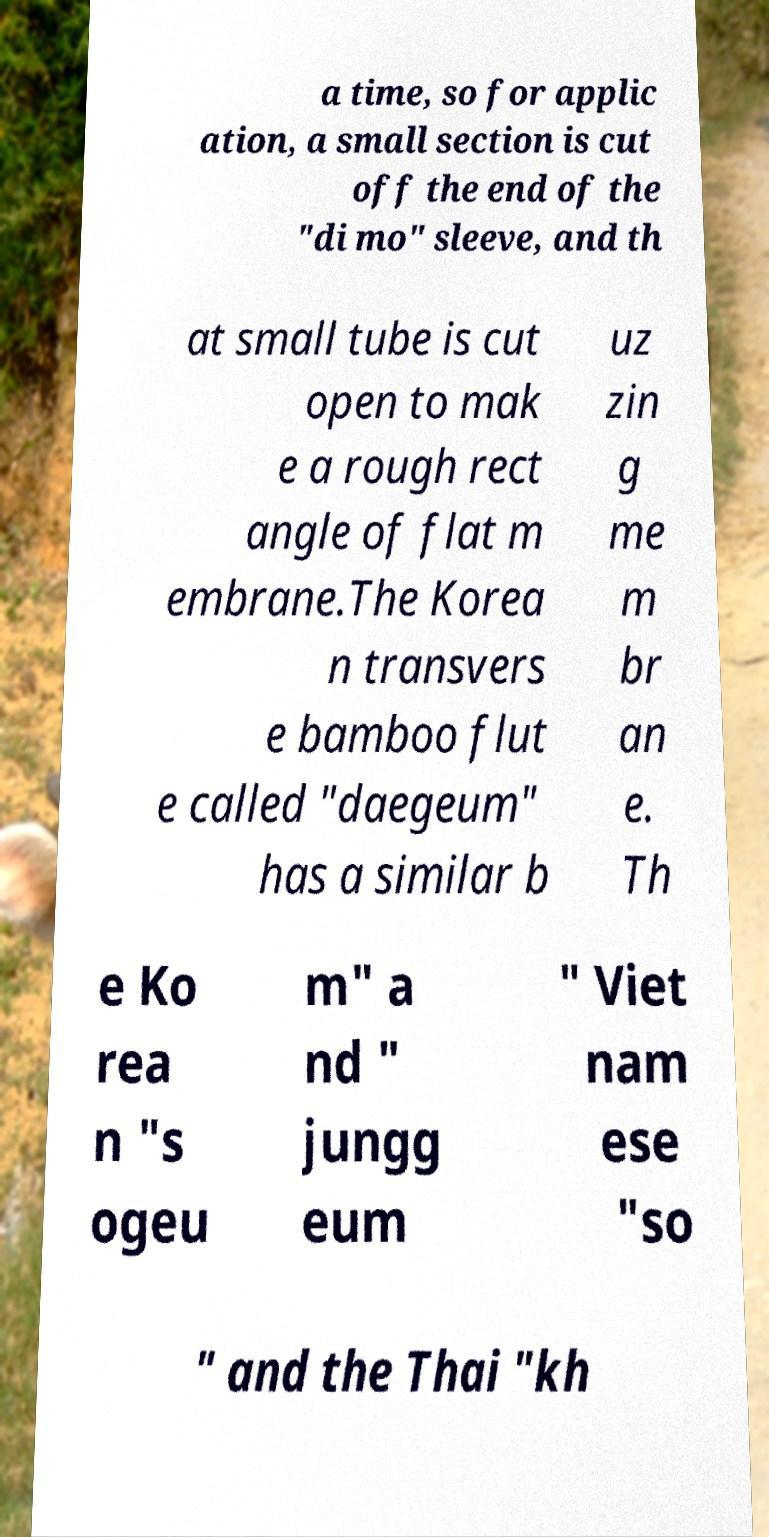Please read and relay the text visible in this image. What does it say? a time, so for applic ation, a small section is cut off the end of the "di mo" sleeve, and th at small tube is cut open to mak e a rough rect angle of flat m embrane.The Korea n transvers e bamboo flut e called "daegeum" has a similar b uz zin g me m br an e. Th e Ko rea n "s ogeu m" a nd " jungg eum " Viet nam ese "so " and the Thai "kh 